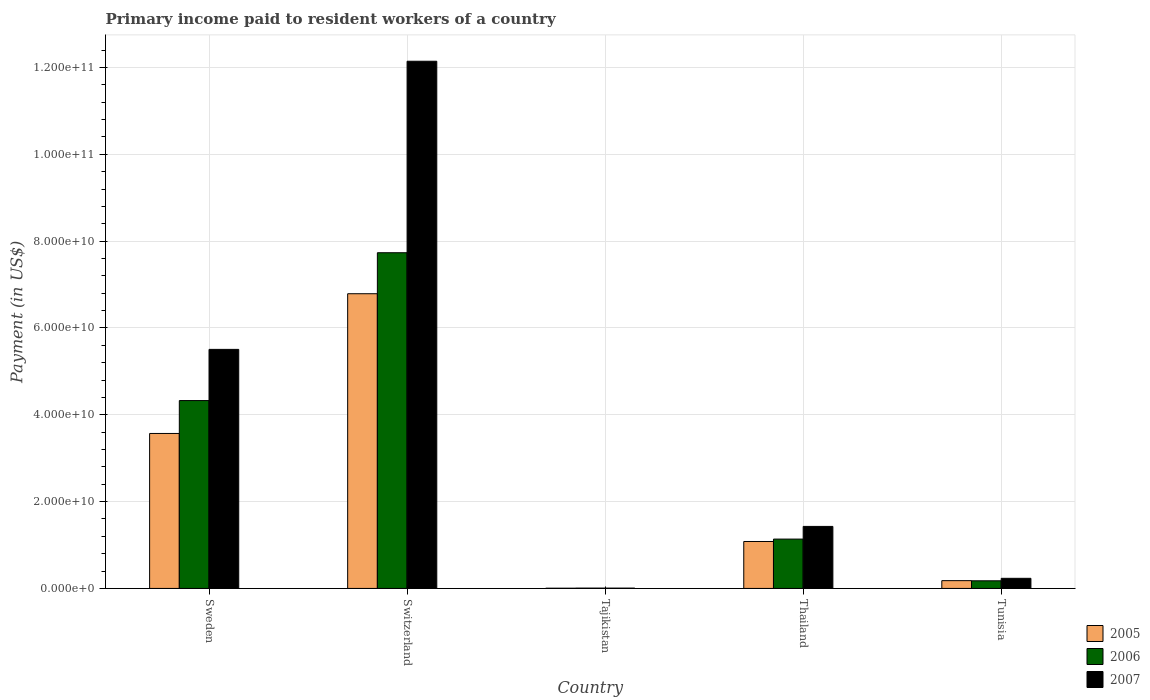How many different coloured bars are there?
Provide a succinct answer. 3. Are the number of bars per tick equal to the number of legend labels?
Make the answer very short. Yes. Are the number of bars on each tick of the X-axis equal?
Offer a very short reply. Yes. What is the label of the 5th group of bars from the left?
Ensure brevity in your answer.  Tunisia. In how many cases, is the number of bars for a given country not equal to the number of legend labels?
Your answer should be very brief. 0. What is the amount paid to workers in 2005 in Tunisia?
Offer a terse response. 1.79e+09. Across all countries, what is the maximum amount paid to workers in 2007?
Provide a succinct answer. 1.21e+11. Across all countries, what is the minimum amount paid to workers in 2006?
Offer a terse response. 7.64e+07. In which country was the amount paid to workers in 2007 maximum?
Your answer should be very brief. Switzerland. In which country was the amount paid to workers in 2005 minimum?
Ensure brevity in your answer.  Tajikistan. What is the total amount paid to workers in 2005 in the graph?
Your answer should be very brief. 1.16e+11. What is the difference between the amount paid to workers in 2007 in Sweden and that in Tajikistan?
Your answer should be compact. 5.50e+1. What is the difference between the amount paid to workers in 2007 in Switzerland and the amount paid to workers in 2006 in Sweden?
Your response must be concise. 7.82e+1. What is the average amount paid to workers in 2005 per country?
Ensure brevity in your answer.  2.32e+1. What is the difference between the amount paid to workers of/in 2006 and amount paid to workers of/in 2005 in Tajikistan?
Offer a terse response. 2.60e+07. What is the ratio of the amount paid to workers in 2007 in Thailand to that in Tunisia?
Ensure brevity in your answer.  6.13. Is the amount paid to workers in 2005 in Tajikistan less than that in Tunisia?
Give a very brief answer. Yes. What is the difference between the highest and the second highest amount paid to workers in 2006?
Give a very brief answer. -3.41e+1. What is the difference between the highest and the lowest amount paid to workers in 2006?
Make the answer very short. 7.73e+1. In how many countries, is the amount paid to workers in 2006 greater than the average amount paid to workers in 2006 taken over all countries?
Offer a very short reply. 2. Is it the case that in every country, the sum of the amount paid to workers in 2007 and amount paid to workers in 2006 is greater than the amount paid to workers in 2005?
Keep it short and to the point. Yes. How many countries are there in the graph?
Your answer should be compact. 5. Are the values on the major ticks of Y-axis written in scientific E-notation?
Keep it short and to the point. Yes. Does the graph contain any zero values?
Provide a short and direct response. No. Where does the legend appear in the graph?
Your answer should be very brief. Bottom right. How many legend labels are there?
Make the answer very short. 3. What is the title of the graph?
Your answer should be compact. Primary income paid to resident workers of a country. What is the label or title of the Y-axis?
Make the answer very short. Payment (in US$). What is the Payment (in US$) of 2005 in Sweden?
Make the answer very short. 3.57e+1. What is the Payment (in US$) in 2006 in Sweden?
Give a very brief answer. 4.33e+1. What is the Payment (in US$) in 2007 in Sweden?
Provide a short and direct response. 5.51e+1. What is the Payment (in US$) of 2005 in Switzerland?
Your answer should be very brief. 6.79e+1. What is the Payment (in US$) in 2006 in Switzerland?
Your answer should be very brief. 7.73e+1. What is the Payment (in US$) of 2007 in Switzerland?
Offer a very short reply. 1.21e+11. What is the Payment (in US$) of 2005 in Tajikistan?
Your answer should be compact. 5.04e+07. What is the Payment (in US$) in 2006 in Tajikistan?
Offer a very short reply. 7.64e+07. What is the Payment (in US$) of 2007 in Tajikistan?
Make the answer very short. 7.32e+07. What is the Payment (in US$) in 2005 in Thailand?
Keep it short and to the point. 1.08e+1. What is the Payment (in US$) in 2006 in Thailand?
Ensure brevity in your answer.  1.14e+1. What is the Payment (in US$) of 2007 in Thailand?
Your answer should be compact. 1.43e+1. What is the Payment (in US$) of 2005 in Tunisia?
Offer a terse response. 1.79e+09. What is the Payment (in US$) in 2006 in Tunisia?
Ensure brevity in your answer.  1.76e+09. What is the Payment (in US$) of 2007 in Tunisia?
Offer a terse response. 2.33e+09. Across all countries, what is the maximum Payment (in US$) in 2005?
Ensure brevity in your answer.  6.79e+1. Across all countries, what is the maximum Payment (in US$) of 2006?
Provide a succinct answer. 7.73e+1. Across all countries, what is the maximum Payment (in US$) in 2007?
Ensure brevity in your answer.  1.21e+11. Across all countries, what is the minimum Payment (in US$) in 2005?
Provide a short and direct response. 5.04e+07. Across all countries, what is the minimum Payment (in US$) in 2006?
Provide a succinct answer. 7.64e+07. Across all countries, what is the minimum Payment (in US$) of 2007?
Ensure brevity in your answer.  7.32e+07. What is the total Payment (in US$) of 2005 in the graph?
Your answer should be compact. 1.16e+11. What is the total Payment (in US$) of 2006 in the graph?
Your response must be concise. 1.34e+11. What is the total Payment (in US$) in 2007 in the graph?
Offer a terse response. 1.93e+11. What is the difference between the Payment (in US$) in 2005 in Sweden and that in Switzerland?
Your answer should be compact. -3.22e+1. What is the difference between the Payment (in US$) in 2006 in Sweden and that in Switzerland?
Provide a short and direct response. -3.41e+1. What is the difference between the Payment (in US$) in 2007 in Sweden and that in Switzerland?
Your response must be concise. -6.64e+1. What is the difference between the Payment (in US$) in 2005 in Sweden and that in Tajikistan?
Your response must be concise. 3.56e+1. What is the difference between the Payment (in US$) in 2006 in Sweden and that in Tajikistan?
Give a very brief answer. 4.32e+1. What is the difference between the Payment (in US$) of 2007 in Sweden and that in Tajikistan?
Keep it short and to the point. 5.50e+1. What is the difference between the Payment (in US$) of 2005 in Sweden and that in Thailand?
Offer a terse response. 2.49e+1. What is the difference between the Payment (in US$) of 2006 in Sweden and that in Thailand?
Make the answer very short. 3.19e+1. What is the difference between the Payment (in US$) in 2007 in Sweden and that in Thailand?
Your answer should be compact. 4.08e+1. What is the difference between the Payment (in US$) of 2005 in Sweden and that in Tunisia?
Your response must be concise. 3.39e+1. What is the difference between the Payment (in US$) in 2006 in Sweden and that in Tunisia?
Ensure brevity in your answer.  4.15e+1. What is the difference between the Payment (in US$) in 2007 in Sweden and that in Tunisia?
Your answer should be very brief. 5.27e+1. What is the difference between the Payment (in US$) of 2005 in Switzerland and that in Tajikistan?
Your answer should be compact. 6.78e+1. What is the difference between the Payment (in US$) in 2006 in Switzerland and that in Tajikistan?
Give a very brief answer. 7.73e+1. What is the difference between the Payment (in US$) in 2007 in Switzerland and that in Tajikistan?
Provide a succinct answer. 1.21e+11. What is the difference between the Payment (in US$) in 2005 in Switzerland and that in Thailand?
Your answer should be very brief. 5.71e+1. What is the difference between the Payment (in US$) of 2006 in Switzerland and that in Thailand?
Offer a very short reply. 6.60e+1. What is the difference between the Payment (in US$) of 2007 in Switzerland and that in Thailand?
Your answer should be very brief. 1.07e+11. What is the difference between the Payment (in US$) of 2005 in Switzerland and that in Tunisia?
Keep it short and to the point. 6.61e+1. What is the difference between the Payment (in US$) of 2006 in Switzerland and that in Tunisia?
Offer a very short reply. 7.56e+1. What is the difference between the Payment (in US$) in 2007 in Switzerland and that in Tunisia?
Give a very brief answer. 1.19e+11. What is the difference between the Payment (in US$) in 2005 in Tajikistan and that in Thailand?
Make the answer very short. -1.08e+1. What is the difference between the Payment (in US$) of 2006 in Tajikistan and that in Thailand?
Provide a succinct answer. -1.13e+1. What is the difference between the Payment (in US$) in 2007 in Tajikistan and that in Thailand?
Ensure brevity in your answer.  -1.42e+1. What is the difference between the Payment (in US$) in 2005 in Tajikistan and that in Tunisia?
Offer a terse response. -1.74e+09. What is the difference between the Payment (in US$) in 2006 in Tajikistan and that in Tunisia?
Provide a short and direct response. -1.68e+09. What is the difference between the Payment (in US$) in 2007 in Tajikistan and that in Tunisia?
Make the answer very short. -2.26e+09. What is the difference between the Payment (in US$) in 2005 in Thailand and that in Tunisia?
Provide a short and direct response. 9.02e+09. What is the difference between the Payment (in US$) of 2006 in Thailand and that in Tunisia?
Provide a succinct answer. 9.61e+09. What is the difference between the Payment (in US$) of 2007 in Thailand and that in Tunisia?
Make the answer very short. 1.20e+1. What is the difference between the Payment (in US$) in 2005 in Sweden and the Payment (in US$) in 2006 in Switzerland?
Keep it short and to the point. -4.16e+1. What is the difference between the Payment (in US$) in 2005 in Sweden and the Payment (in US$) in 2007 in Switzerland?
Offer a very short reply. -8.57e+1. What is the difference between the Payment (in US$) in 2006 in Sweden and the Payment (in US$) in 2007 in Switzerland?
Your response must be concise. -7.82e+1. What is the difference between the Payment (in US$) of 2005 in Sweden and the Payment (in US$) of 2006 in Tajikistan?
Your response must be concise. 3.56e+1. What is the difference between the Payment (in US$) of 2005 in Sweden and the Payment (in US$) of 2007 in Tajikistan?
Provide a succinct answer. 3.56e+1. What is the difference between the Payment (in US$) of 2006 in Sweden and the Payment (in US$) of 2007 in Tajikistan?
Provide a succinct answer. 4.32e+1. What is the difference between the Payment (in US$) of 2005 in Sweden and the Payment (in US$) of 2006 in Thailand?
Ensure brevity in your answer.  2.43e+1. What is the difference between the Payment (in US$) of 2005 in Sweden and the Payment (in US$) of 2007 in Thailand?
Offer a terse response. 2.14e+1. What is the difference between the Payment (in US$) in 2006 in Sweden and the Payment (in US$) in 2007 in Thailand?
Your answer should be compact. 2.90e+1. What is the difference between the Payment (in US$) of 2005 in Sweden and the Payment (in US$) of 2006 in Tunisia?
Your response must be concise. 3.39e+1. What is the difference between the Payment (in US$) in 2005 in Sweden and the Payment (in US$) in 2007 in Tunisia?
Give a very brief answer. 3.34e+1. What is the difference between the Payment (in US$) of 2006 in Sweden and the Payment (in US$) of 2007 in Tunisia?
Make the answer very short. 4.09e+1. What is the difference between the Payment (in US$) of 2005 in Switzerland and the Payment (in US$) of 2006 in Tajikistan?
Keep it short and to the point. 6.78e+1. What is the difference between the Payment (in US$) in 2005 in Switzerland and the Payment (in US$) in 2007 in Tajikistan?
Your response must be concise. 6.78e+1. What is the difference between the Payment (in US$) in 2006 in Switzerland and the Payment (in US$) in 2007 in Tajikistan?
Keep it short and to the point. 7.73e+1. What is the difference between the Payment (in US$) of 2005 in Switzerland and the Payment (in US$) of 2006 in Thailand?
Keep it short and to the point. 5.65e+1. What is the difference between the Payment (in US$) in 2005 in Switzerland and the Payment (in US$) in 2007 in Thailand?
Your answer should be very brief. 5.36e+1. What is the difference between the Payment (in US$) in 2006 in Switzerland and the Payment (in US$) in 2007 in Thailand?
Make the answer very short. 6.30e+1. What is the difference between the Payment (in US$) in 2005 in Switzerland and the Payment (in US$) in 2006 in Tunisia?
Your answer should be very brief. 6.61e+1. What is the difference between the Payment (in US$) of 2005 in Switzerland and the Payment (in US$) of 2007 in Tunisia?
Ensure brevity in your answer.  6.56e+1. What is the difference between the Payment (in US$) in 2006 in Switzerland and the Payment (in US$) in 2007 in Tunisia?
Your response must be concise. 7.50e+1. What is the difference between the Payment (in US$) of 2005 in Tajikistan and the Payment (in US$) of 2006 in Thailand?
Make the answer very short. -1.13e+1. What is the difference between the Payment (in US$) in 2005 in Tajikistan and the Payment (in US$) in 2007 in Thailand?
Make the answer very short. -1.42e+1. What is the difference between the Payment (in US$) in 2006 in Tajikistan and the Payment (in US$) in 2007 in Thailand?
Your answer should be compact. -1.42e+1. What is the difference between the Payment (in US$) of 2005 in Tajikistan and the Payment (in US$) of 2006 in Tunisia?
Give a very brief answer. -1.71e+09. What is the difference between the Payment (in US$) of 2005 in Tajikistan and the Payment (in US$) of 2007 in Tunisia?
Keep it short and to the point. -2.28e+09. What is the difference between the Payment (in US$) of 2006 in Tajikistan and the Payment (in US$) of 2007 in Tunisia?
Offer a very short reply. -2.25e+09. What is the difference between the Payment (in US$) in 2005 in Thailand and the Payment (in US$) in 2006 in Tunisia?
Your answer should be very brief. 9.06e+09. What is the difference between the Payment (in US$) of 2005 in Thailand and the Payment (in US$) of 2007 in Tunisia?
Offer a terse response. 8.48e+09. What is the difference between the Payment (in US$) of 2006 in Thailand and the Payment (in US$) of 2007 in Tunisia?
Give a very brief answer. 9.04e+09. What is the average Payment (in US$) in 2005 per country?
Your answer should be very brief. 2.32e+1. What is the average Payment (in US$) of 2006 per country?
Your answer should be very brief. 2.68e+1. What is the average Payment (in US$) in 2007 per country?
Your answer should be very brief. 3.86e+1. What is the difference between the Payment (in US$) of 2005 and Payment (in US$) of 2006 in Sweden?
Your answer should be very brief. -7.57e+09. What is the difference between the Payment (in US$) in 2005 and Payment (in US$) in 2007 in Sweden?
Your response must be concise. -1.94e+1. What is the difference between the Payment (in US$) in 2006 and Payment (in US$) in 2007 in Sweden?
Provide a short and direct response. -1.18e+1. What is the difference between the Payment (in US$) in 2005 and Payment (in US$) in 2006 in Switzerland?
Keep it short and to the point. -9.45e+09. What is the difference between the Payment (in US$) of 2005 and Payment (in US$) of 2007 in Switzerland?
Your response must be concise. -5.36e+1. What is the difference between the Payment (in US$) of 2006 and Payment (in US$) of 2007 in Switzerland?
Give a very brief answer. -4.41e+1. What is the difference between the Payment (in US$) of 2005 and Payment (in US$) of 2006 in Tajikistan?
Ensure brevity in your answer.  -2.60e+07. What is the difference between the Payment (in US$) of 2005 and Payment (in US$) of 2007 in Tajikistan?
Provide a succinct answer. -2.28e+07. What is the difference between the Payment (in US$) in 2006 and Payment (in US$) in 2007 in Tajikistan?
Your answer should be very brief. 3.18e+06. What is the difference between the Payment (in US$) in 2005 and Payment (in US$) in 2006 in Thailand?
Provide a succinct answer. -5.56e+08. What is the difference between the Payment (in US$) of 2005 and Payment (in US$) of 2007 in Thailand?
Your response must be concise. -3.47e+09. What is the difference between the Payment (in US$) in 2006 and Payment (in US$) in 2007 in Thailand?
Keep it short and to the point. -2.92e+09. What is the difference between the Payment (in US$) in 2005 and Payment (in US$) in 2006 in Tunisia?
Provide a short and direct response. 3.87e+07. What is the difference between the Payment (in US$) of 2005 and Payment (in US$) of 2007 in Tunisia?
Provide a succinct answer. -5.35e+08. What is the difference between the Payment (in US$) in 2006 and Payment (in US$) in 2007 in Tunisia?
Your answer should be very brief. -5.73e+08. What is the ratio of the Payment (in US$) in 2005 in Sweden to that in Switzerland?
Ensure brevity in your answer.  0.53. What is the ratio of the Payment (in US$) of 2006 in Sweden to that in Switzerland?
Provide a succinct answer. 0.56. What is the ratio of the Payment (in US$) of 2007 in Sweden to that in Switzerland?
Offer a very short reply. 0.45. What is the ratio of the Payment (in US$) in 2005 in Sweden to that in Tajikistan?
Keep it short and to the point. 708.84. What is the ratio of the Payment (in US$) of 2006 in Sweden to that in Tajikistan?
Make the answer very short. 566.77. What is the ratio of the Payment (in US$) in 2007 in Sweden to that in Tajikistan?
Offer a very short reply. 752.6. What is the ratio of the Payment (in US$) of 2005 in Sweden to that in Thailand?
Make the answer very short. 3.3. What is the ratio of the Payment (in US$) of 2006 in Sweden to that in Thailand?
Offer a terse response. 3.81. What is the ratio of the Payment (in US$) of 2007 in Sweden to that in Thailand?
Your answer should be compact. 3.85. What is the ratio of the Payment (in US$) in 2005 in Sweden to that in Tunisia?
Provide a short and direct response. 19.89. What is the ratio of the Payment (in US$) of 2006 in Sweden to that in Tunisia?
Offer a terse response. 24.65. What is the ratio of the Payment (in US$) in 2007 in Sweden to that in Tunisia?
Provide a succinct answer. 23.64. What is the ratio of the Payment (in US$) in 2005 in Switzerland to that in Tajikistan?
Ensure brevity in your answer.  1347.9. What is the ratio of the Payment (in US$) in 2006 in Switzerland to that in Tajikistan?
Your answer should be very brief. 1012.85. What is the ratio of the Payment (in US$) of 2007 in Switzerland to that in Tajikistan?
Offer a very short reply. 1659.76. What is the ratio of the Payment (in US$) in 2005 in Switzerland to that in Thailand?
Your response must be concise. 6.28. What is the ratio of the Payment (in US$) in 2006 in Switzerland to that in Thailand?
Offer a terse response. 6.8. What is the ratio of the Payment (in US$) in 2007 in Switzerland to that in Thailand?
Make the answer very short. 8.5. What is the ratio of the Payment (in US$) of 2005 in Switzerland to that in Tunisia?
Your answer should be very brief. 37.83. What is the ratio of the Payment (in US$) in 2006 in Switzerland to that in Tunisia?
Provide a short and direct response. 44.04. What is the ratio of the Payment (in US$) of 2007 in Switzerland to that in Tunisia?
Offer a terse response. 52.14. What is the ratio of the Payment (in US$) in 2005 in Tajikistan to that in Thailand?
Make the answer very short. 0. What is the ratio of the Payment (in US$) in 2006 in Tajikistan to that in Thailand?
Keep it short and to the point. 0.01. What is the ratio of the Payment (in US$) of 2007 in Tajikistan to that in Thailand?
Your answer should be compact. 0.01. What is the ratio of the Payment (in US$) in 2005 in Tajikistan to that in Tunisia?
Your answer should be very brief. 0.03. What is the ratio of the Payment (in US$) of 2006 in Tajikistan to that in Tunisia?
Keep it short and to the point. 0.04. What is the ratio of the Payment (in US$) of 2007 in Tajikistan to that in Tunisia?
Offer a terse response. 0.03. What is the ratio of the Payment (in US$) of 2005 in Thailand to that in Tunisia?
Make the answer very short. 6.02. What is the ratio of the Payment (in US$) of 2006 in Thailand to that in Tunisia?
Ensure brevity in your answer.  6.47. What is the ratio of the Payment (in US$) in 2007 in Thailand to that in Tunisia?
Your response must be concise. 6.13. What is the difference between the highest and the second highest Payment (in US$) of 2005?
Give a very brief answer. 3.22e+1. What is the difference between the highest and the second highest Payment (in US$) in 2006?
Provide a short and direct response. 3.41e+1. What is the difference between the highest and the second highest Payment (in US$) of 2007?
Your answer should be compact. 6.64e+1. What is the difference between the highest and the lowest Payment (in US$) in 2005?
Provide a succinct answer. 6.78e+1. What is the difference between the highest and the lowest Payment (in US$) of 2006?
Offer a terse response. 7.73e+1. What is the difference between the highest and the lowest Payment (in US$) of 2007?
Your response must be concise. 1.21e+11. 